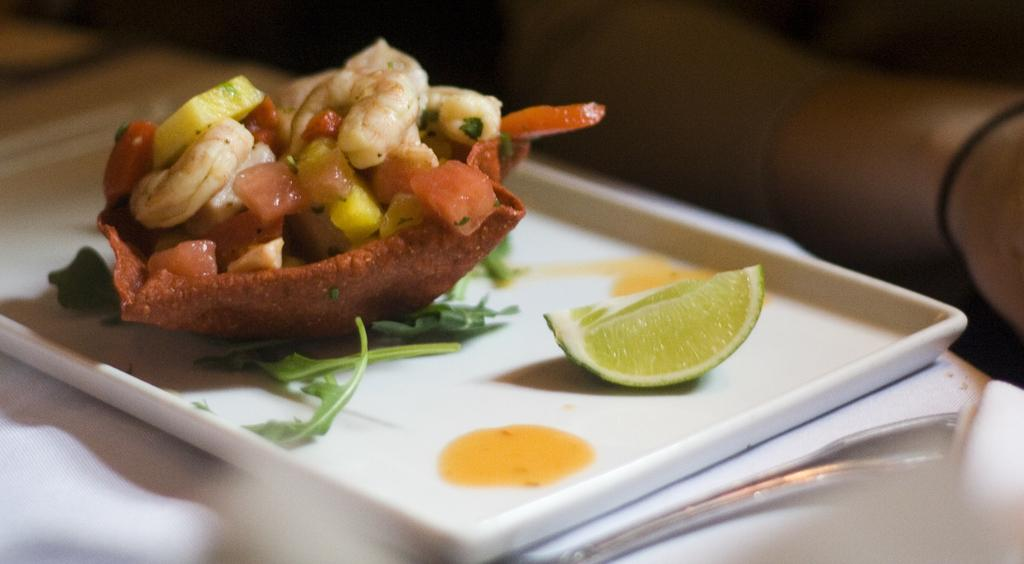What is on the plate that is visible in the image? There is food on a plate in the image. How many sticks are used to support the food on the plate in the image? There is no mention of sticks in the image, as it only shows food on a plate. 